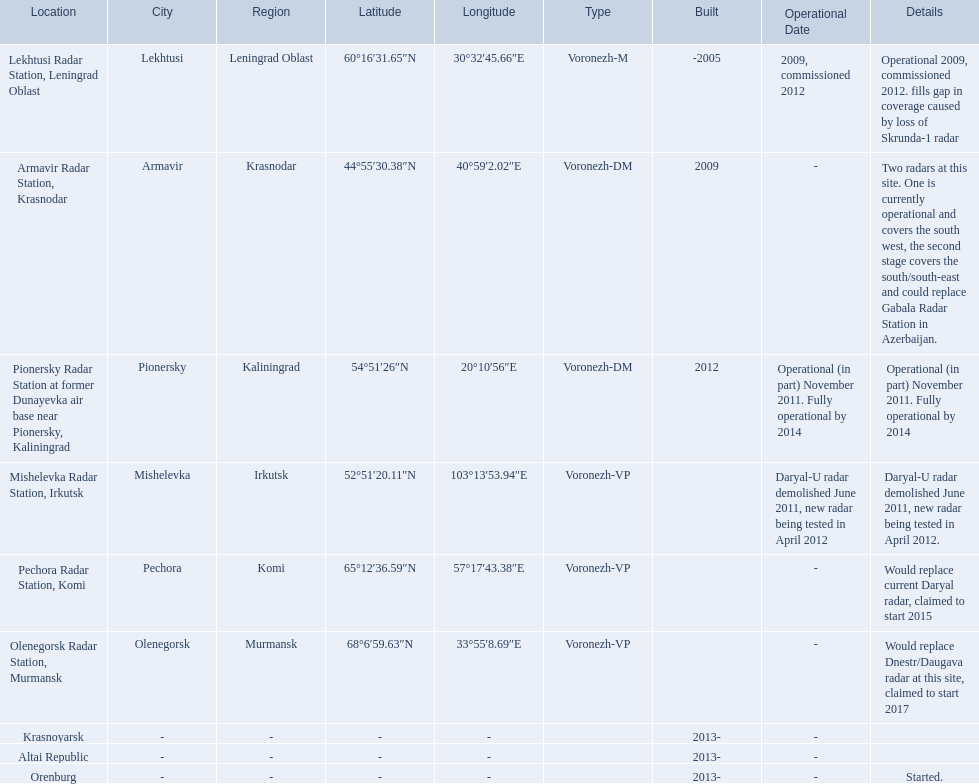Where is each radar? Lekhtusi Radar Station, Leningrad Oblast, Armavir Radar Station, Krasnodar, Pionersky Radar Station at former Dunayevka air base near Pionersky, Kaliningrad, Mishelevka Radar Station, Irkutsk, Pechora Radar Station, Komi, Olenegorsk Radar Station, Murmansk, Krasnoyarsk, Altai Republic, Orenburg. What are the details of each radar? Operational 2009, commissioned 2012. fills gap in coverage caused by loss of Skrunda-1 radar, Two radars at this site. One is currently operational and covers the south west, the second stage covers the south/south-east and could replace Gabala Radar Station in Azerbaijan., Operational (in part) November 2011. Fully operational by 2014, Daryal-U radar demolished June 2011, new radar being tested in April 2012., Would replace current Daryal radar, claimed to start 2015, Would replace Dnestr/Daugava radar at this site, claimed to start 2017, , , Started. Which radar is detailed to start in 2015? Pechora Radar Station, Komi. 